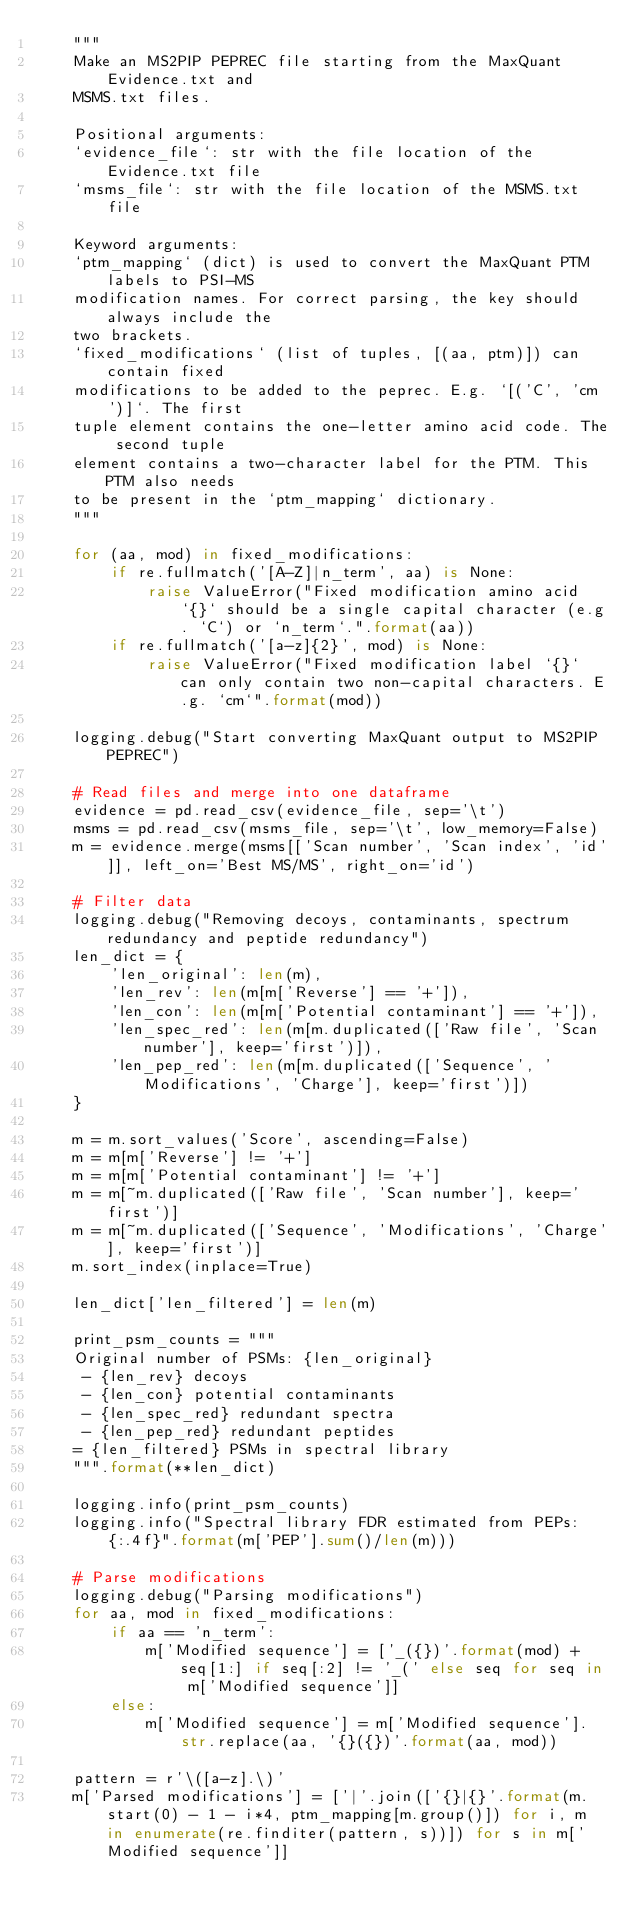Convert code to text. <code><loc_0><loc_0><loc_500><loc_500><_Python_>    """
    Make an MS2PIP PEPREC file starting from the MaxQuant Evidence.txt and
    MSMS.txt files.

    Positional arguments:
    `evidence_file`: str with the file location of the Evidence.txt file
    `msms_file`: str with the file location of the MSMS.txt file

    Keyword arguments:
    `ptm_mapping` (dict) is used to convert the MaxQuant PTM labels to PSI-MS
    modification names. For correct parsing, the key should always include the
    two brackets.
    `fixed_modifications` (list of tuples, [(aa, ptm)]) can contain fixed
    modifications to be added to the peprec. E.g. `[('C', 'cm')]`. The first
    tuple element contains the one-letter amino acid code. The second tuple
    element contains a two-character label for the PTM. This PTM also needs
    to be present in the `ptm_mapping` dictionary.
    """

    for (aa, mod) in fixed_modifications:
        if re.fullmatch('[A-Z]|n_term', aa) is None:
            raise ValueError("Fixed modification amino acid `{}` should be a single capital character (e.g. `C`) or `n_term`.".format(aa))
        if re.fullmatch('[a-z]{2}', mod) is None:
            raise ValueError("Fixed modification label `{}` can only contain two non-capital characters. E.g. `cm`".format(mod))

    logging.debug("Start converting MaxQuant output to MS2PIP PEPREC")

    # Read files and merge into one dataframe
    evidence = pd.read_csv(evidence_file, sep='\t')
    msms = pd.read_csv(msms_file, sep='\t', low_memory=False)
    m = evidence.merge(msms[['Scan number', 'Scan index', 'id']], left_on='Best MS/MS', right_on='id')

    # Filter data
    logging.debug("Removing decoys, contaminants, spectrum redundancy and peptide redundancy")
    len_dict = {
        'len_original': len(m),
        'len_rev': len(m[m['Reverse'] == '+']),
        'len_con': len(m[m['Potential contaminant'] == '+']),
        'len_spec_red': len(m[m.duplicated(['Raw file', 'Scan number'], keep='first')]),
        'len_pep_red': len(m[m.duplicated(['Sequence', 'Modifications', 'Charge'], keep='first')])
    }

    m = m.sort_values('Score', ascending=False)
    m = m[m['Reverse'] != '+']
    m = m[m['Potential contaminant'] != '+']
    m = m[~m.duplicated(['Raw file', 'Scan number'], keep='first')]
    m = m[~m.duplicated(['Sequence', 'Modifications', 'Charge'], keep='first')]
    m.sort_index(inplace=True)

    len_dict['len_filtered'] = len(m)

    print_psm_counts = """
    Original number of PSMs: {len_original}
     - {len_rev} decoys
     - {len_con} potential contaminants
     - {len_spec_red} redundant spectra
     - {len_pep_red} redundant peptides
    = {len_filtered} PSMs in spectral library
    """.format(**len_dict)

    logging.info(print_psm_counts)
    logging.info("Spectral library FDR estimated from PEPs: {:.4f}".format(m['PEP'].sum()/len(m)))

    # Parse modifications
    logging.debug("Parsing modifications")
    for aa, mod in fixed_modifications:
        if aa == 'n_term':
            m['Modified sequence'] = ['_({})'.format(mod) + seq[1:] if seq[:2] != '_(' else seq for seq in m['Modified sequence']]
        else:
            m['Modified sequence'] = m['Modified sequence'].str.replace(aa, '{}({})'.format(aa, mod))

    pattern = r'\([a-z].\)'
    m['Parsed modifications'] = ['|'.join(['{}|{}'.format(m.start(0) - 1 - i*4, ptm_mapping[m.group()]) for i, m in enumerate(re.finditer(pattern, s))]) for s in m['Modified sequence']]</code> 